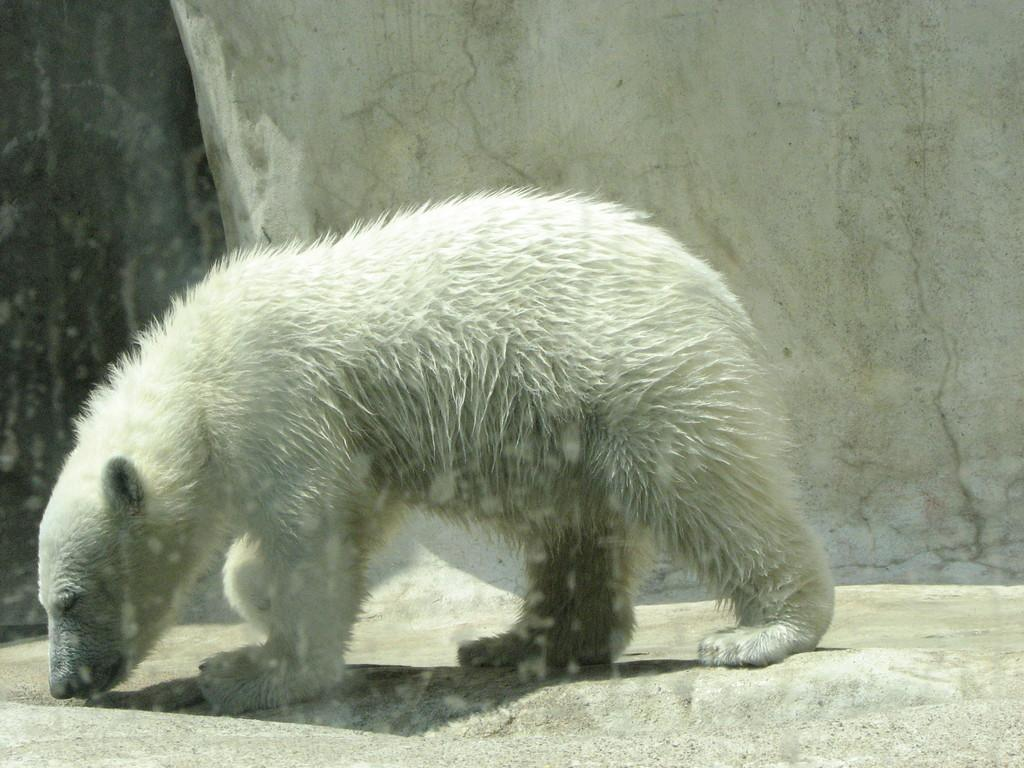What type of animal is in the image? There is a white-colored polar bear in the image. Where is the polar bear located in the image? The polar bear is in the front of the image. What can be seen in the background of the image? There is a wall visible in the background of the image. What type of powder is being used by the polar bear in the image? There is no powder present in the image, and the polar bear is not using any. 